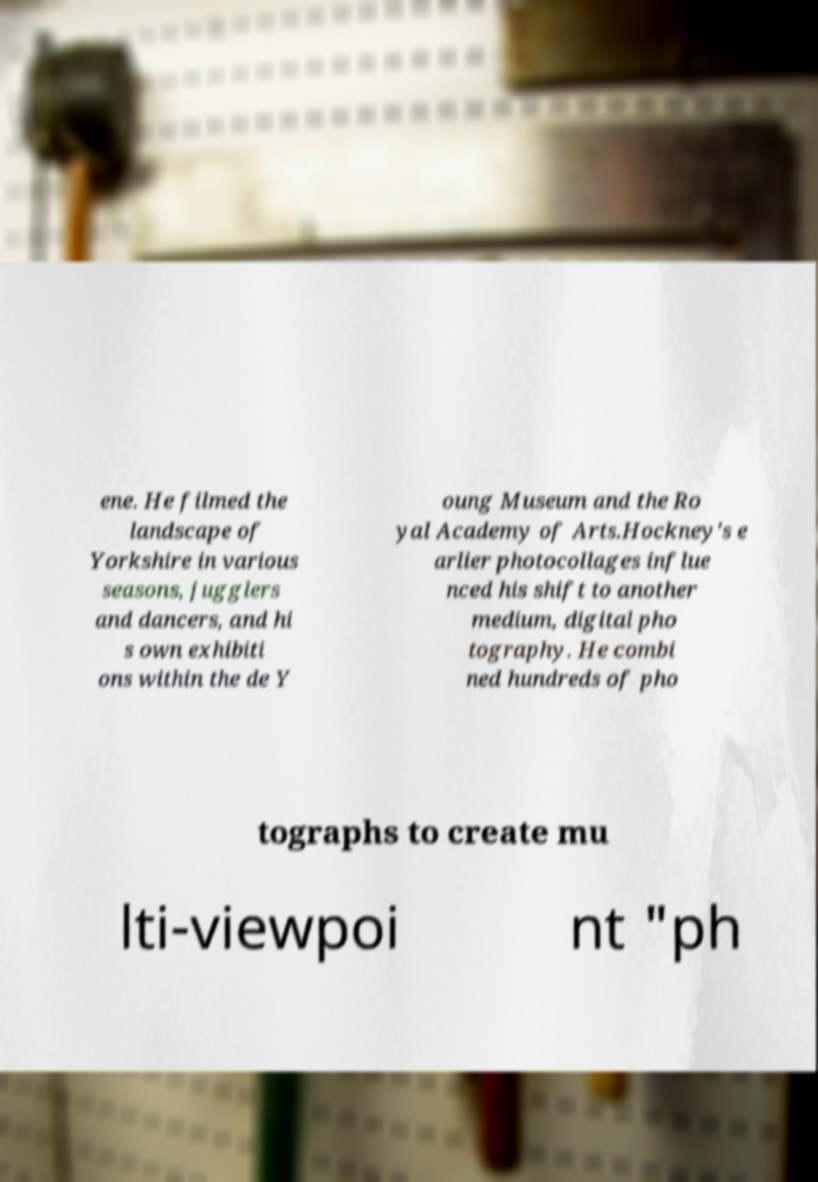Please read and relay the text visible in this image. What does it say? ene. He filmed the landscape of Yorkshire in various seasons, jugglers and dancers, and hi s own exhibiti ons within the de Y oung Museum and the Ro yal Academy of Arts.Hockney's e arlier photocollages influe nced his shift to another medium, digital pho tography. He combi ned hundreds of pho tographs to create mu lti-viewpoi nt "ph 